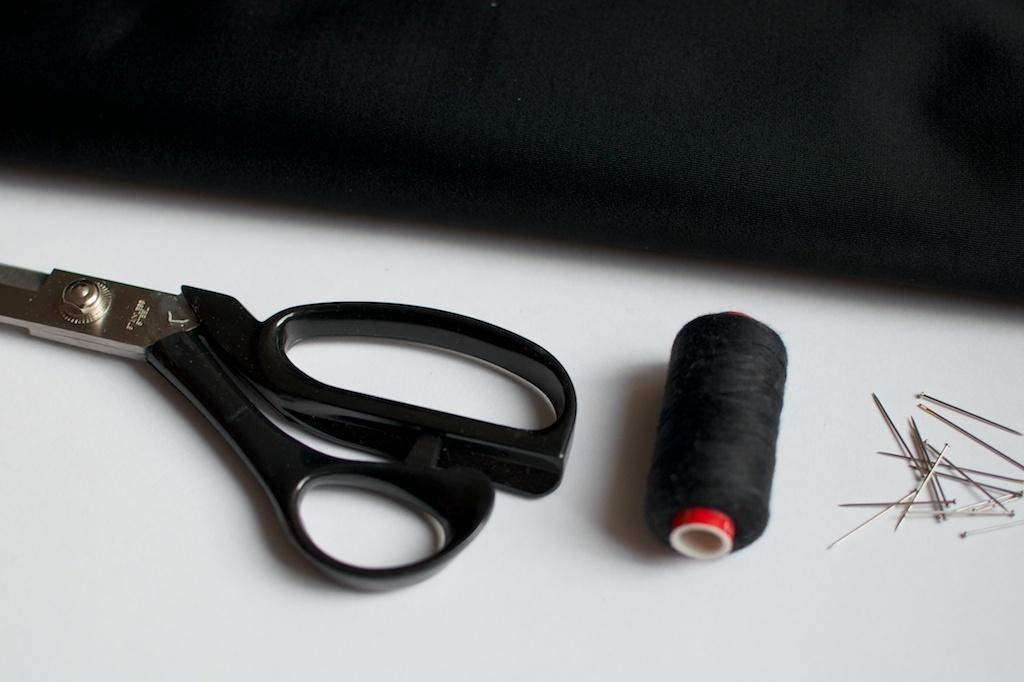What is the primary color of the surface in the image? The primary color of the surface in the image is white. What objects can be seen on the white surface? There is a pair of scissors, thread, and needles on the white surface. What might these objects be used for? These objects might be used for sewing or crafting. Can you describe the motion of the person in the image? There is no person present in the image, so there is no motion to describe. 